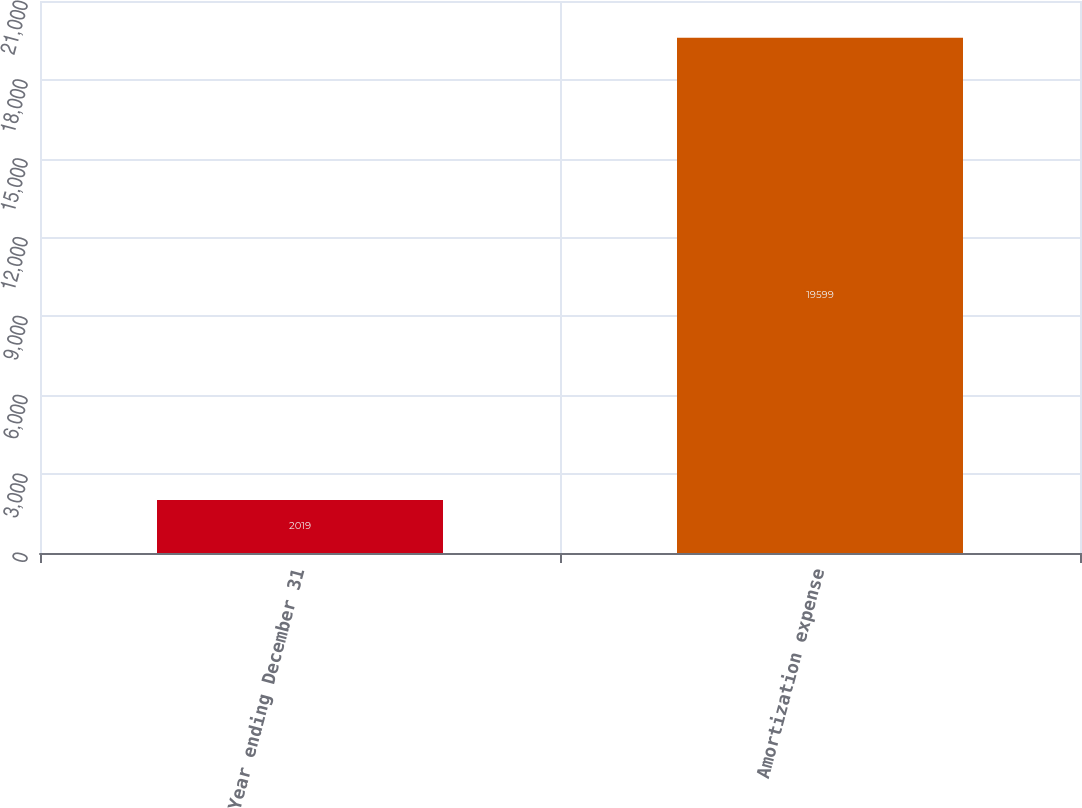Convert chart. <chart><loc_0><loc_0><loc_500><loc_500><bar_chart><fcel>Year ending December 31<fcel>Amortization expense<nl><fcel>2019<fcel>19599<nl></chart> 